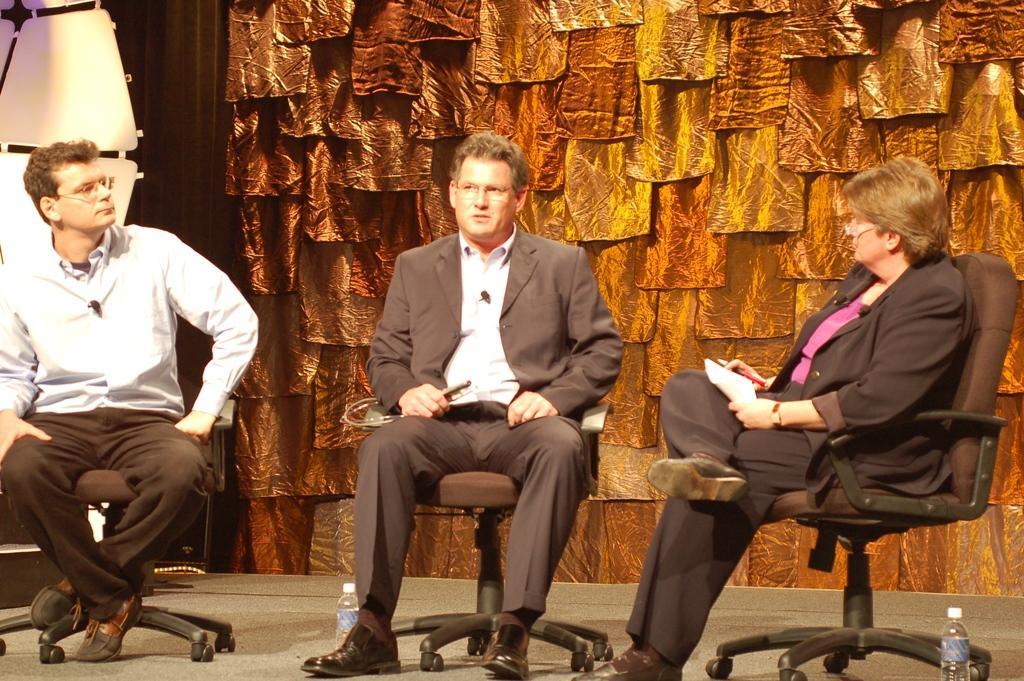Please provide a concise description of this image. this picture shows three people sitting on a chair and a woman holding a paper in her hand 